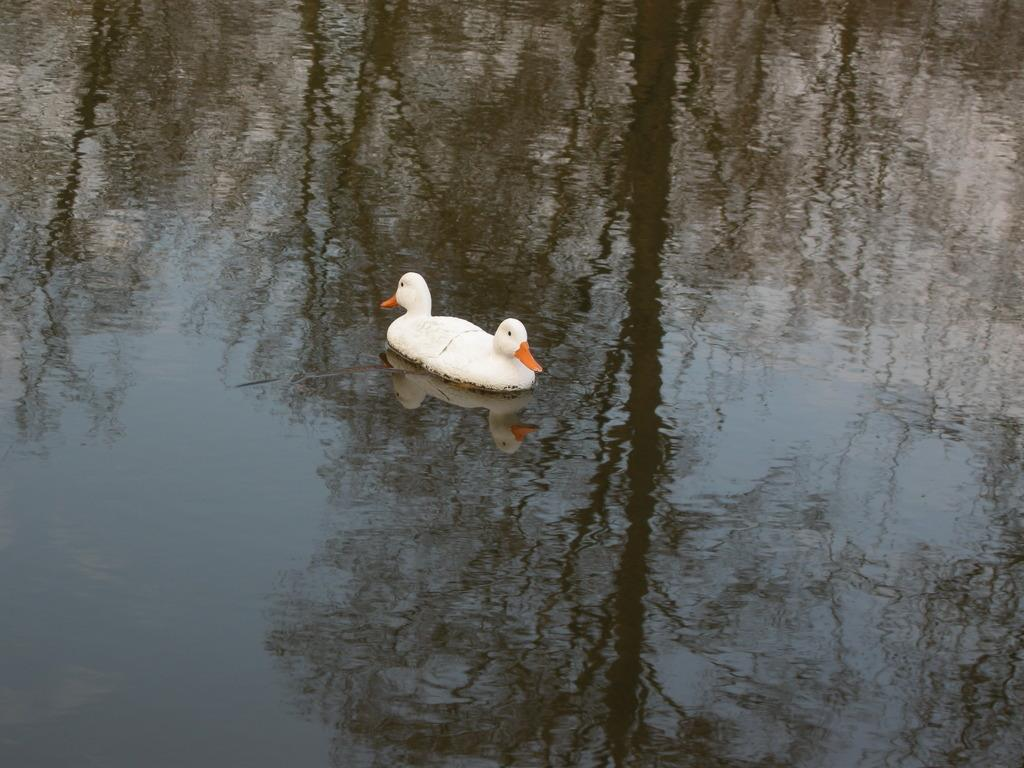What type of animals are in the image? There are white color ducks in the image. What is the primary element in which the ducks are situated? There is water visible in the image. What can be seen in the reflection of the water? There is a reflection of trees in the water. How many pizzas can be seen in the image? There are no pizzas present in the image. What is the front of the ducks facing in the image? The provided facts do not specify the direction the ducks are facing, so it cannot be determined from the image. 